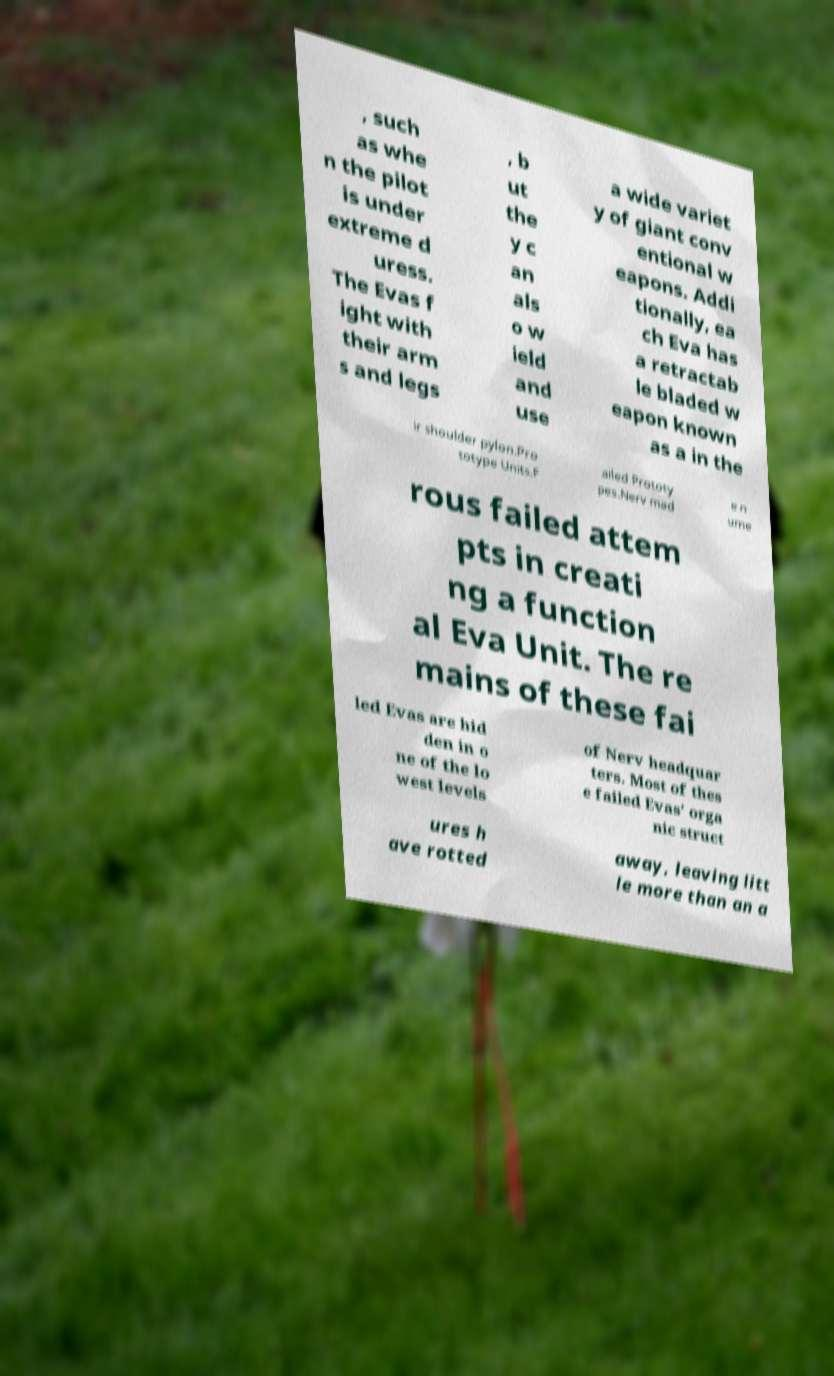Please read and relay the text visible in this image. What does it say? , such as whe n the pilot is under extreme d uress. The Evas f ight with their arm s and legs , b ut the y c an als o w ield and use a wide variet y of giant conv entional w eapons. Addi tionally, ea ch Eva has a retractab le bladed w eapon known as a in the ir shoulder pylon.Pro totype Units.F ailed Prototy pes.Nerv mad e n ume rous failed attem pts in creati ng a function al Eva Unit. The re mains of these fai led Evas are hid den in o ne of the lo west levels of Nerv headquar ters. Most of thes e failed Evas' orga nic struct ures h ave rotted away, leaving litt le more than an a 